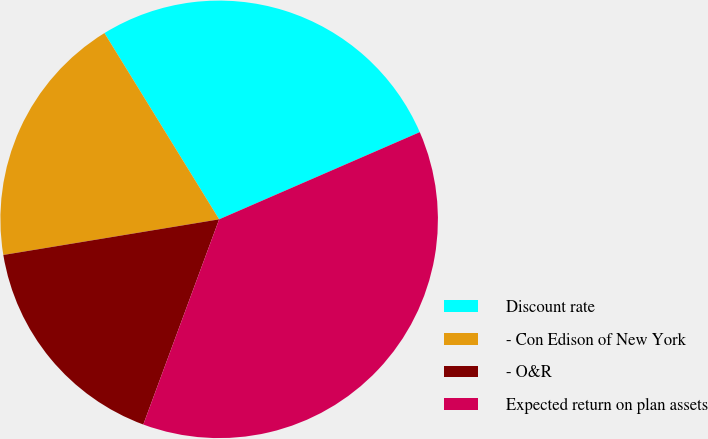Convert chart to OTSL. <chart><loc_0><loc_0><loc_500><loc_500><pie_chart><fcel>Discount rate<fcel>- Con Edison of New York<fcel>- O&R<fcel>Expected return on plan assets<nl><fcel>27.26%<fcel>18.82%<fcel>16.76%<fcel>37.16%<nl></chart> 